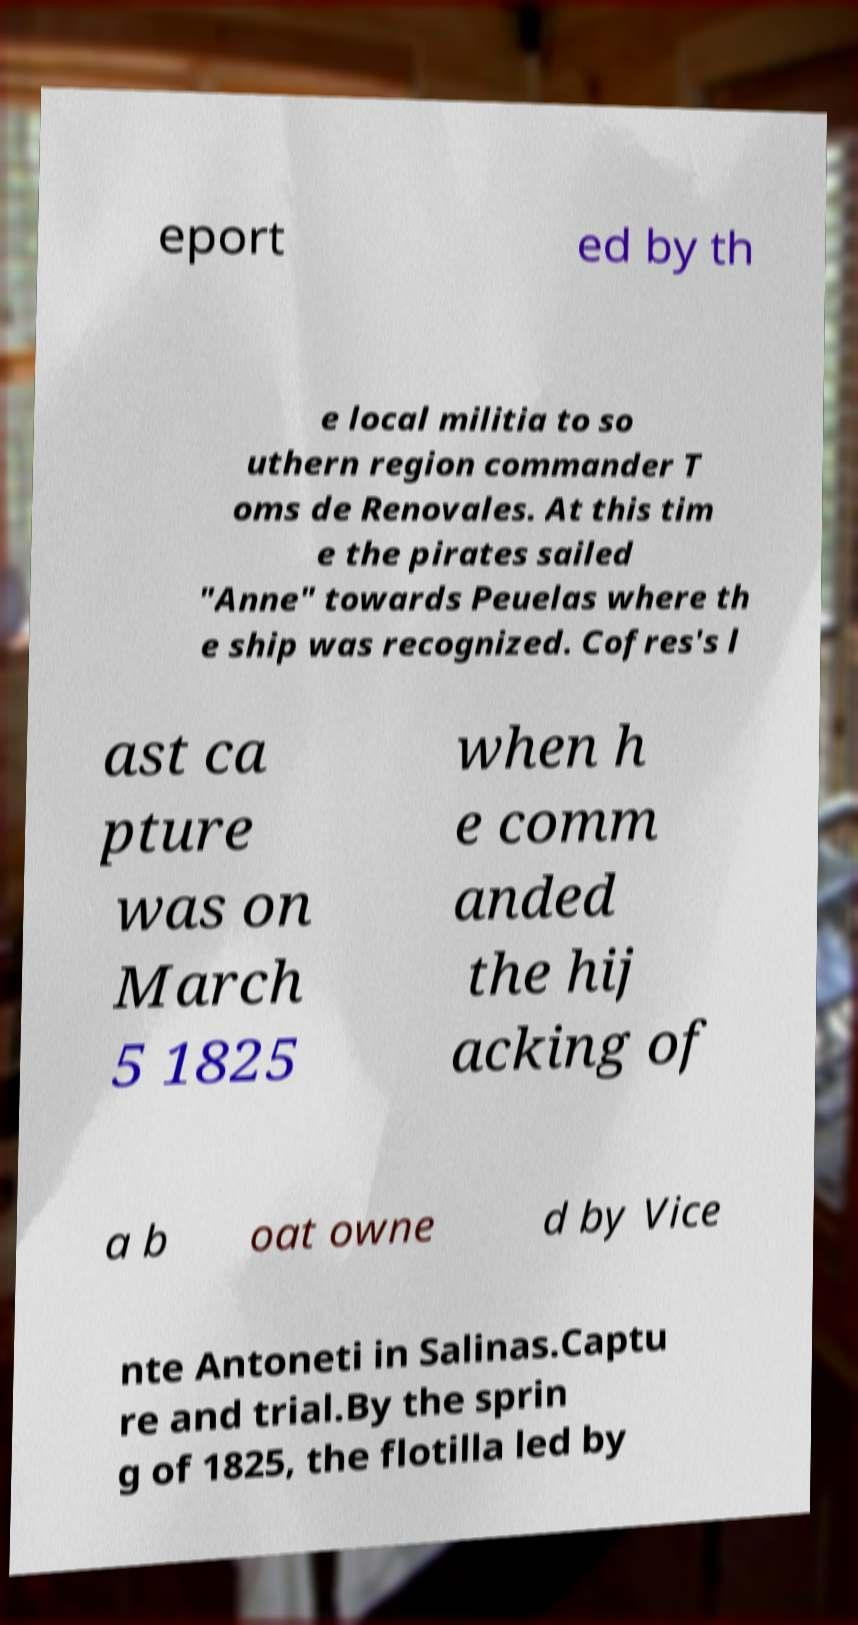Could you extract and type out the text from this image? eport ed by th e local militia to so uthern region commander T oms de Renovales. At this tim e the pirates sailed "Anne" towards Peuelas where th e ship was recognized. Cofres's l ast ca pture was on March 5 1825 when h e comm anded the hij acking of a b oat owne d by Vice nte Antoneti in Salinas.Captu re and trial.By the sprin g of 1825, the flotilla led by 